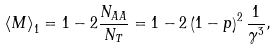Convert formula to latex. <formula><loc_0><loc_0><loc_500><loc_500>\left \langle M \right \rangle _ { 1 } = 1 - 2 \frac { N _ { A A } } { N _ { T } } = 1 - 2 \left ( 1 - p \right ) ^ { 2 } \frac { 1 } { \gamma ^ { 3 } } ,</formula> 